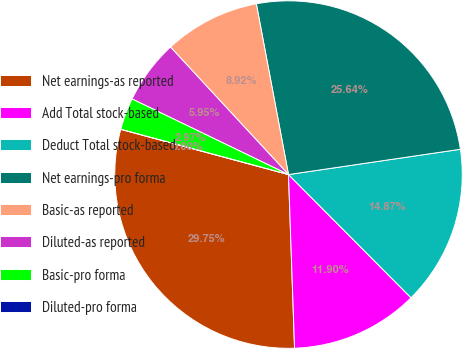Convert chart. <chart><loc_0><loc_0><loc_500><loc_500><pie_chart><fcel>Net earnings-as reported<fcel>Add Total stock-based<fcel>Deduct Total stock-based<fcel>Net earnings-pro forma<fcel>Basic-as reported<fcel>Diluted-as reported<fcel>Basic-pro forma<fcel>Diluted-pro forma<nl><fcel>29.75%<fcel>11.9%<fcel>14.87%<fcel>25.64%<fcel>8.92%<fcel>5.95%<fcel>2.97%<fcel>0.0%<nl></chart> 